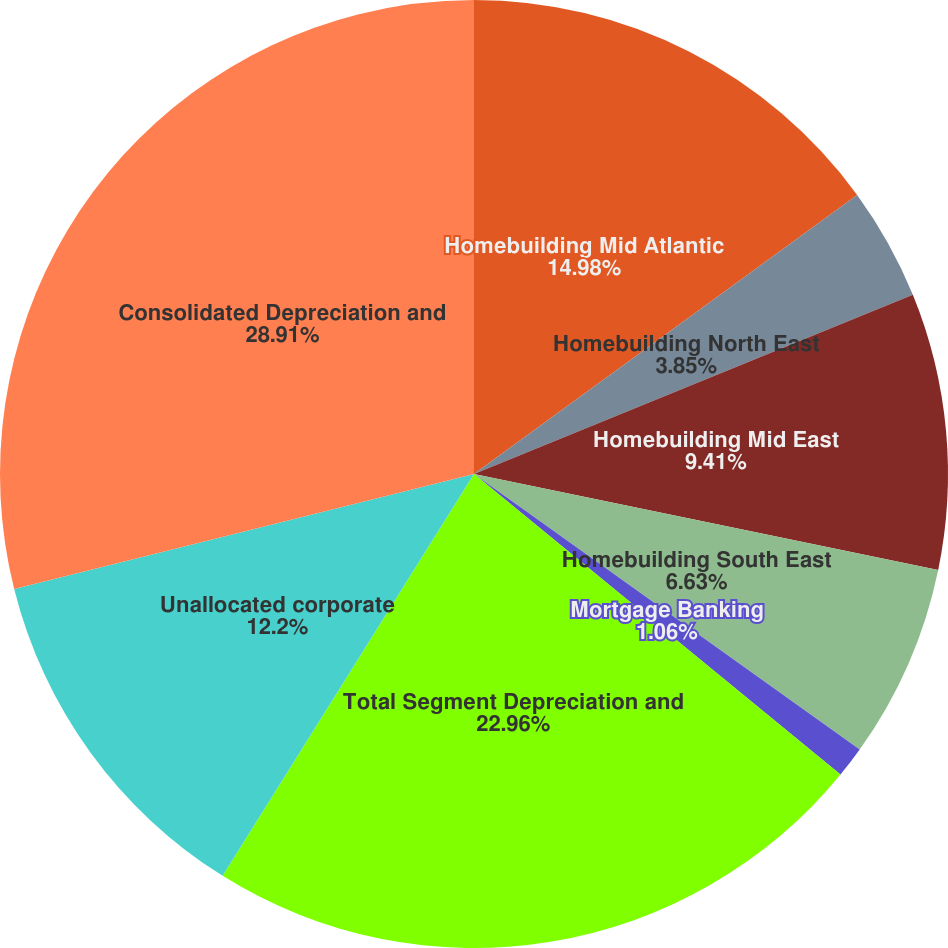<chart> <loc_0><loc_0><loc_500><loc_500><pie_chart><fcel>Homebuilding Mid Atlantic<fcel>Homebuilding North East<fcel>Homebuilding Mid East<fcel>Homebuilding South East<fcel>Mortgage Banking<fcel>Total Segment Depreciation and<fcel>Unallocated corporate<fcel>Consolidated Depreciation and<nl><fcel>14.98%<fcel>3.85%<fcel>9.41%<fcel>6.63%<fcel>1.06%<fcel>22.96%<fcel>12.2%<fcel>28.9%<nl></chart> 